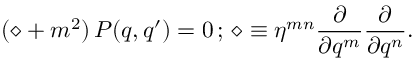Convert formula to latex. <formula><loc_0><loc_0><loc_500><loc_500>( \diamond + m ^ { 2 } ) \, P ( q , q ^ { \prime } ) = 0 \, ; \, \diamond \equiv \eta ^ { m n } \frac { \partial } { \partial q ^ { m } } \frac { \partial } { \partial q ^ { n } } .</formula> 